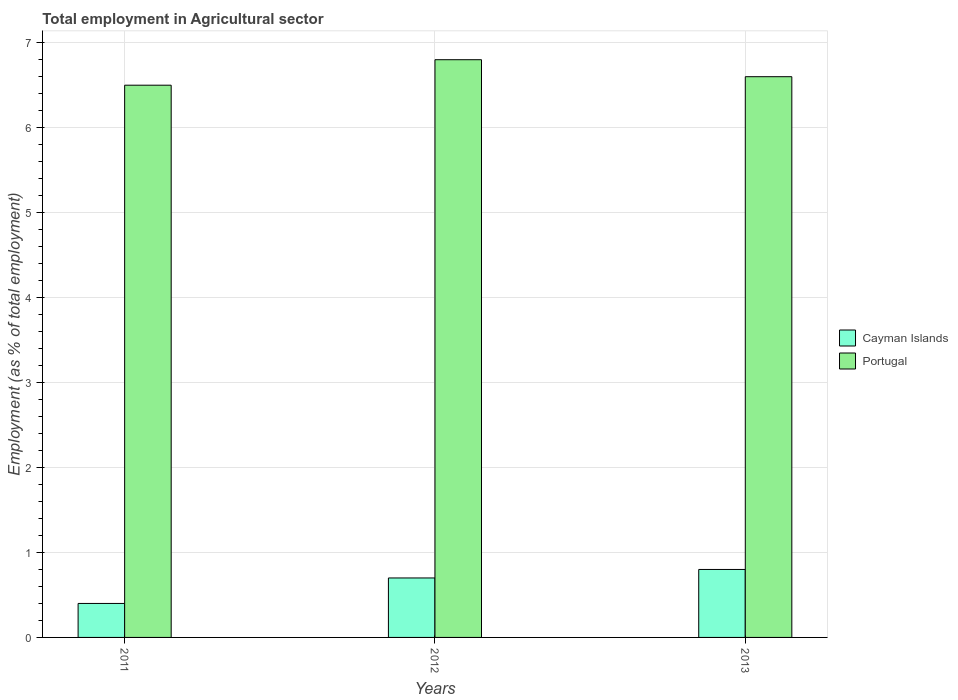How many groups of bars are there?
Give a very brief answer. 3. Are the number of bars on each tick of the X-axis equal?
Provide a succinct answer. Yes. How many bars are there on the 2nd tick from the left?
Make the answer very short. 2. How many bars are there on the 1st tick from the right?
Your answer should be very brief. 2. What is the employment in agricultural sector in Cayman Islands in 2012?
Provide a succinct answer. 0.7. Across all years, what is the maximum employment in agricultural sector in Cayman Islands?
Ensure brevity in your answer.  0.8. Across all years, what is the minimum employment in agricultural sector in Cayman Islands?
Your answer should be compact. 0.4. In which year was the employment in agricultural sector in Cayman Islands minimum?
Offer a very short reply. 2011. What is the total employment in agricultural sector in Portugal in the graph?
Ensure brevity in your answer.  19.9. What is the difference between the employment in agricultural sector in Portugal in 2012 and that in 2013?
Provide a succinct answer. 0.2. What is the difference between the employment in agricultural sector in Cayman Islands in 2011 and the employment in agricultural sector in Portugal in 2013?
Your answer should be very brief. -6.2. What is the average employment in agricultural sector in Cayman Islands per year?
Ensure brevity in your answer.  0.63. In the year 2013, what is the difference between the employment in agricultural sector in Cayman Islands and employment in agricultural sector in Portugal?
Offer a terse response. -5.8. In how many years, is the employment in agricultural sector in Cayman Islands greater than 6.4 %?
Provide a short and direct response. 0. What is the difference between the highest and the second highest employment in agricultural sector in Cayman Islands?
Give a very brief answer. 0.1. What is the difference between the highest and the lowest employment in agricultural sector in Cayman Islands?
Offer a very short reply. 0.4. Is the sum of the employment in agricultural sector in Portugal in 2011 and 2012 greater than the maximum employment in agricultural sector in Cayman Islands across all years?
Keep it short and to the point. Yes. Are all the bars in the graph horizontal?
Your answer should be compact. No. How many years are there in the graph?
Give a very brief answer. 3. How many legend labels are there?
Make the answer very short. 2. How are the legend labels stacked?
Keep it short and to the point. Vertical. What is the title of the graph?
Offer a very short reply. Total employment in Agricultural sector. What is the label or title of the X-axis?
Offer a very short reply. Years. What is the label or title of the Y-axis?
Give a very brief answer. Employment (as % of total employment). What is the Employment (as % of total employment) of Cayman Islands in 2011?
Keep it short and to the point. 0.4. What is the Employment (as % of total employment) in Portugal in 2011?
Provide a succinct answer. 6.5. What is the Employment (as % of total employment) of Cayman Islands in 2012?
Offer a very short reply. 0.7. What is the Employment (as % of total employment) in Portugal in 2012?
Your response must be concise. 6.8. What is the Employment (as % of total employment) of Cayman Islands in 2013?
Ensure brevity in your answer.  0.8. What is the Employment (as % of total employment) in Portugal in 2013?
Offer a very short reply. 6.6. Across all years, what is the maximum Employment (as % of total employment) of Cayman Islands?
Ensure brevity in your answer.  0.8. Across all years, what is the maximum Employment (as % of total employment) in Portugal?
Your response must be concise. 6.8. Across all years, what is the minimum Employment (as % of total employment) of Cayman Islands?
Your response must be concise. 0.4. Across all years, what is the minimum Employment (as % of total employment) of Portugal?
Give a very brief answer. 6.5. What is the total Employment (as % of total employment) in Cayman Islands in the graph?
Your answer should be very brief. 1.9. What is the total Employment (as % of total employment) of Portugal in the graph?
Make the answer very short. 19.9. What is the difference between the Employment (as % of total employment) in Portugal in 2011 and that in 2012?
Your answer should be very brief. -0.3. What is the difference between the Employment (as % of total employment) of Portugal in 2011 and that in 2013?
Your answer should be compact. -0.1. What is the difference between the Employment (as % of total employment) of Portugal in 2012 and that in 2013?
Offer a very short reply. 0.2. What is the difference between the Employment (as % of total employment) in Cayman Islands in 2011 and the Employment (as % of total employment) in Portugal in 2012?
Keep it short and to the point. -6.4. What is the average Employment (as % of total employment) of Cayman Islands per year?
Provide a succinct answer. 0.63. What is the average Employment (as % of total employment) in Portugal per year?
Provide a succinct answer. 6.63. In the year 2011, what is the difference between the Employment (as % of total employment) in Cayman Islands and Employment (as % of total employment) in Portugal?
Provide a succinct answer. -6.1. In the year 2013, what is the difference between the Employment (as % of total employment) in Cayman Islands and Employment (as % of total employment) in Portugal?
Your answer should be very brief. -5.8. What is the ratio of the Employment (as % of total employment) of Cayman Islands in 2011 to that in 2012?
Offer a terse response. 0.57. What is the ratio of the Employment (as % of total employment) of Portugal in 2011 to that in 2012?
Ensure brevity in your answer.  0.96. What is the ratio of the Employment (as % of total employment) in Cayman Islands in 2011 to that in 2013?
Keep it short and to the point. 0.5. What is the ratio of the Employment (as % of total employment) of Cayman Islands in 2012 to that in 2013?
Make the answer very short. 0.88. What is the ratio of the Employment (as % of total employment) in Portugal in 2012 to that in 2013?
Make the answer very short. 1.03. What is the difference between the highest and the second highest Employment (as % of total employment) in Portugal?
Provide a short and direct response. 0.2. What is the difference between the highest and the lowest Employment (as % of total employment) of Cayman Islands?
Ensure brevity in your answer.  0.4. What is the difference between the highest and the lowest Employment (as % of total employment) in Portugal?
Give a very brief answer. 0.3. 